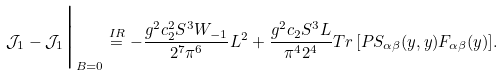<formula> <loc_0><loc_0><loc_500><loc_500>\mathcal { J } _ { 1 } - \mathcal { J } _ { 1 } \Big | _ { B = 0 } \stackrel { I R } { = } - \frac { g ^ { 2 } c _ { 2 } ^ { 2 } S ^ { 3 } W _ { - 1 } } { 2 ^ { 7 } \pi ^ { 6 } } L ^ { 2 } + \frac { g ^ { 2 } c _ { 2 } S ^ { 3 } L } { \pi ^ { 4 } 2 ^ { 4 } } T r \, [ P S _ { \alpha \beta } ( y , y ) F _ { \alpha \beta } ( y ) ] .</formula> 